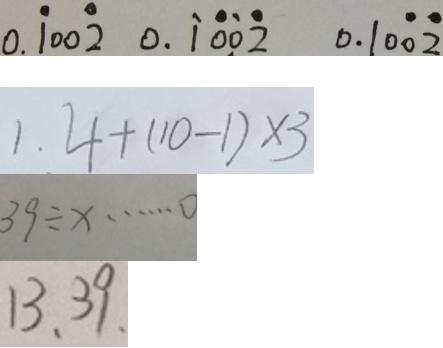Convert formula to latex. <formula><loc_0><loc_0><loc_500><loc_500>0 . \dot { 1 } 0 0 \dot { 2 } 0 . \dot { 1 } \dot { 0 } \dot { 0 } \dot { 2 } 0 . 1 0 \dot { 0 } \dot { 2 } 
 1 . 4 + ( 1 0 - 1 ) \times 3 
 3 9 \div x \cdots 0 
 1 3 、 3 9 、</formula> 